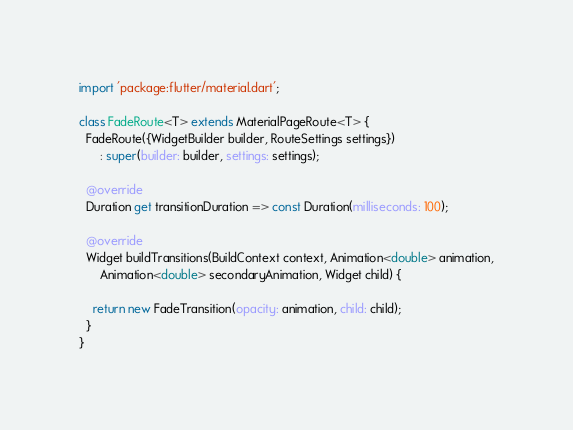<code> <loc_0><loc_0><loc_500><loc_500><_Dart_>import 'package:flutter/material.dart';

class FadeRoute<T> extends MaterialPageRoute<T> {
  FadeRoute({WidgetBuilder builder, RouteSettings settings})
      : super(builder: builder, settings: settings);

  @override
  Duration get transitionDuration => const Duration(milliseconds: 100);

  @override
  Widget buildTransitions(BuildContext context, Animation<double> animation,
      Animation<double> secondaryAnimation, Widget child) {
    
    return new FadeTransition(opacity: animation, child: child);
  }
}
</code> 